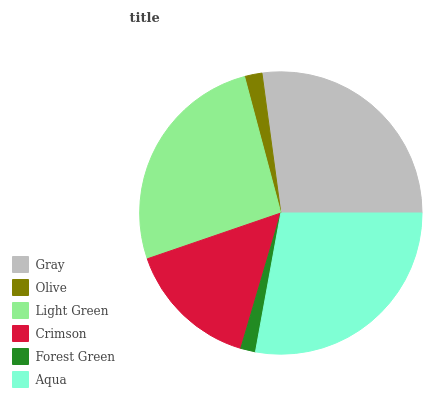Is Forest Green the minimum?
Answer yes or no. Yes. Is Aqua the maximum?
Answer yes or no. Yes. Is Olive the minimum?
Answer yes or no. No. Is Olive the maximum?
Answer yes or no. No. Is Gray greater than Olive?
Answer yes or no. Yes. Is Olive less than Gray?
Answer yes or no. Yes. Is Olive greater than Gray?
Answer yes or no. No. Is Gray less than Olive?
Answer yes or no. No. Is Light Green the high median?
Answer yes or no. Yes. Is Crimson the low median?
Answer yes or no. Yes. Is Aqua the high median?
Answer yes or no. No. Is Light Green the low median?
Answer yes or no. No. 